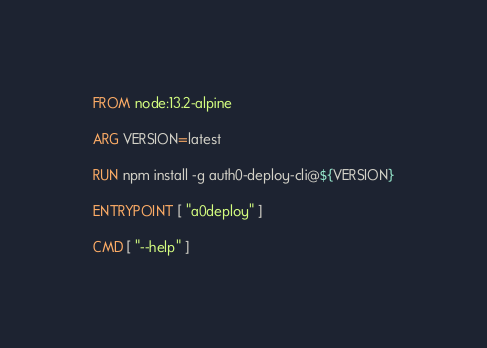Convert code to text. <code><loc_0><loc_0><loc_500><loc_500><_Dockerfile_>FROM node:13.2-alpine

ARG VERSION=latest

RUN npm install -g auth0-deploy-cli@${VERSION}

ENTRYPOINT [ "a0deploy" ]

CMD [ "--help" ]
</code> 